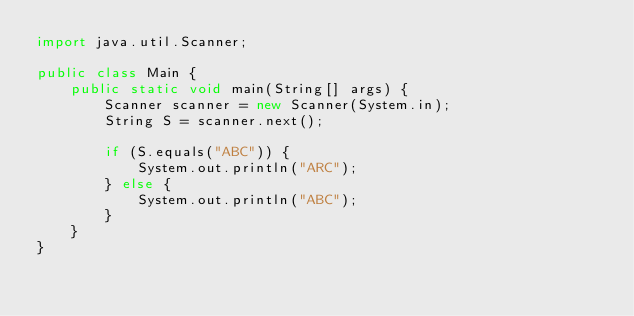Convert code to text. <code><loc_0><loc_0><loc_500><loc_500><_Java_>import java.util.Scanner;

public class Main {
    public static void main(String[] args) {
        Scanner scanner = new Scanner(System.in);
        String S = scanner.next();

        if (S.equals("ABC")) {
            System.out.println("ARC");
        } else {
            System.out.println("ABC");
        }
    }
}
</code> 